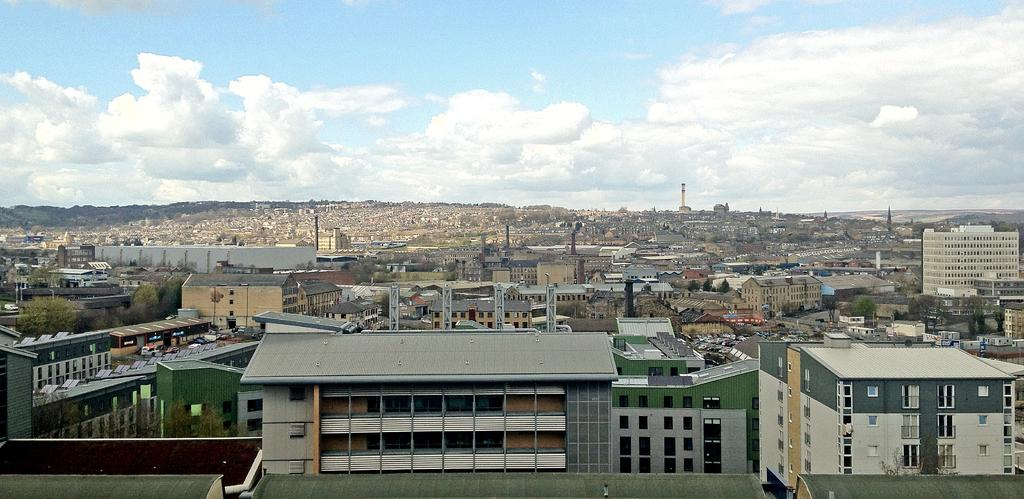What type of structures can be seen in the image? There are buildings in the image. Where are the trees located in the image? The trees are on the left side of the image. What can be seen in the sky in the background of the image? There are clouds in the sky in the background of the image. What type of skin is visible on the shelf in the image? There is no shelf or skin present in the image. 